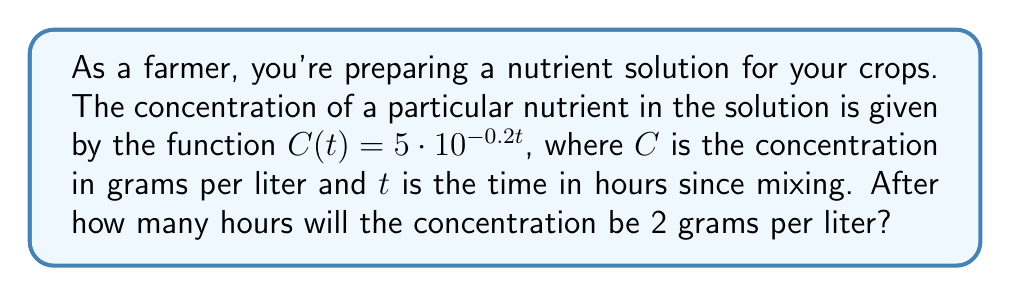Show me your answer to this math problem. Let's solve this step-by-step:

1) We need to find $t$ when $C(t) = 2$. So, we set up the equation:

   $2 = 5 \cdot 10^{-0.2t}$

2) Divide both sides by 5:

   $\frac{2}{5} = 10^{-0.2t}$

3) Take the logarithm (base 10) of both sides:

   $\log_{10}(\frac{2}{5}) = \log_{10}(10^{-0.2t})$

4) Using the logarithm property $\log_a(a^x) = x$, the right side simplifies to:

   $\log_{10}(\frac{2}{5}) = -0.2t$

5) Solve for $t$:

   $t = -\frac{\log_{10}(\frac{2}{5})}{0.2}$

6) Calculate the value:

   $t = -\frac{\log_{10}(0.4)}{0.2} \approx 4.98$ hours

7) Round to the nearest tenth of an hour:

   $t \approx 5.0$ hours
Answer: 5.0 hours 